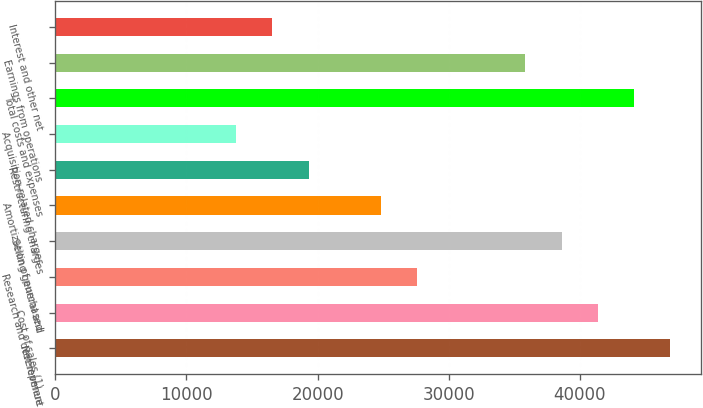Convert chart to OTSL. <chart><loc_0><loc_0><loc_500><loc_500><bar_chart><fcel>Net revenue<fcel>Cost of sales (1)<fcel>Research and development<fcel>Selling general and<fcel>Amortization of purchased<fcel>Restructuring charges<fcel>Acquisition-related charges<fcel>Total costs and expenses<fcel>Earnings from operations<fcel>Interest and other net<nl><fcel>46894.4<fcel>41377.4<fcel>27585<fcel>38618.9<fcel>24826.5<fcel>19309.5<fcel>13792.5<fcel>44135.9<fcel>35860.4<fcel>16551<nl></chart> 